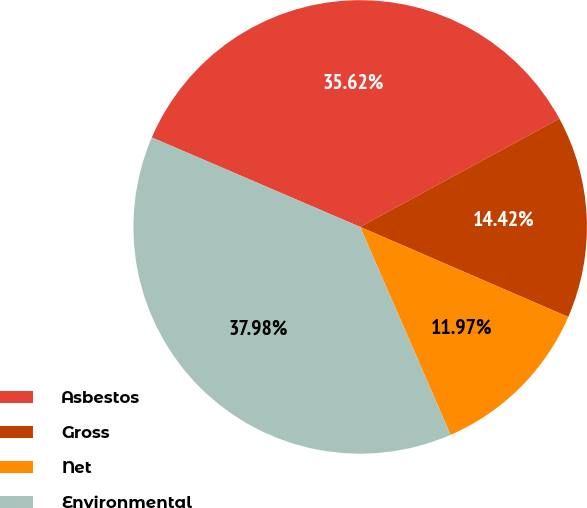<chart> <loc_0><loc_0><loc_500><loc_500><pie_chart><fcel>Asbestos<fcel>Gross<fcel>Net<fcel>Environmental<nl><fcel>35.62%<fcel>14.42%<fcel>11.97%<fcel>37.98%<nl></chart> 